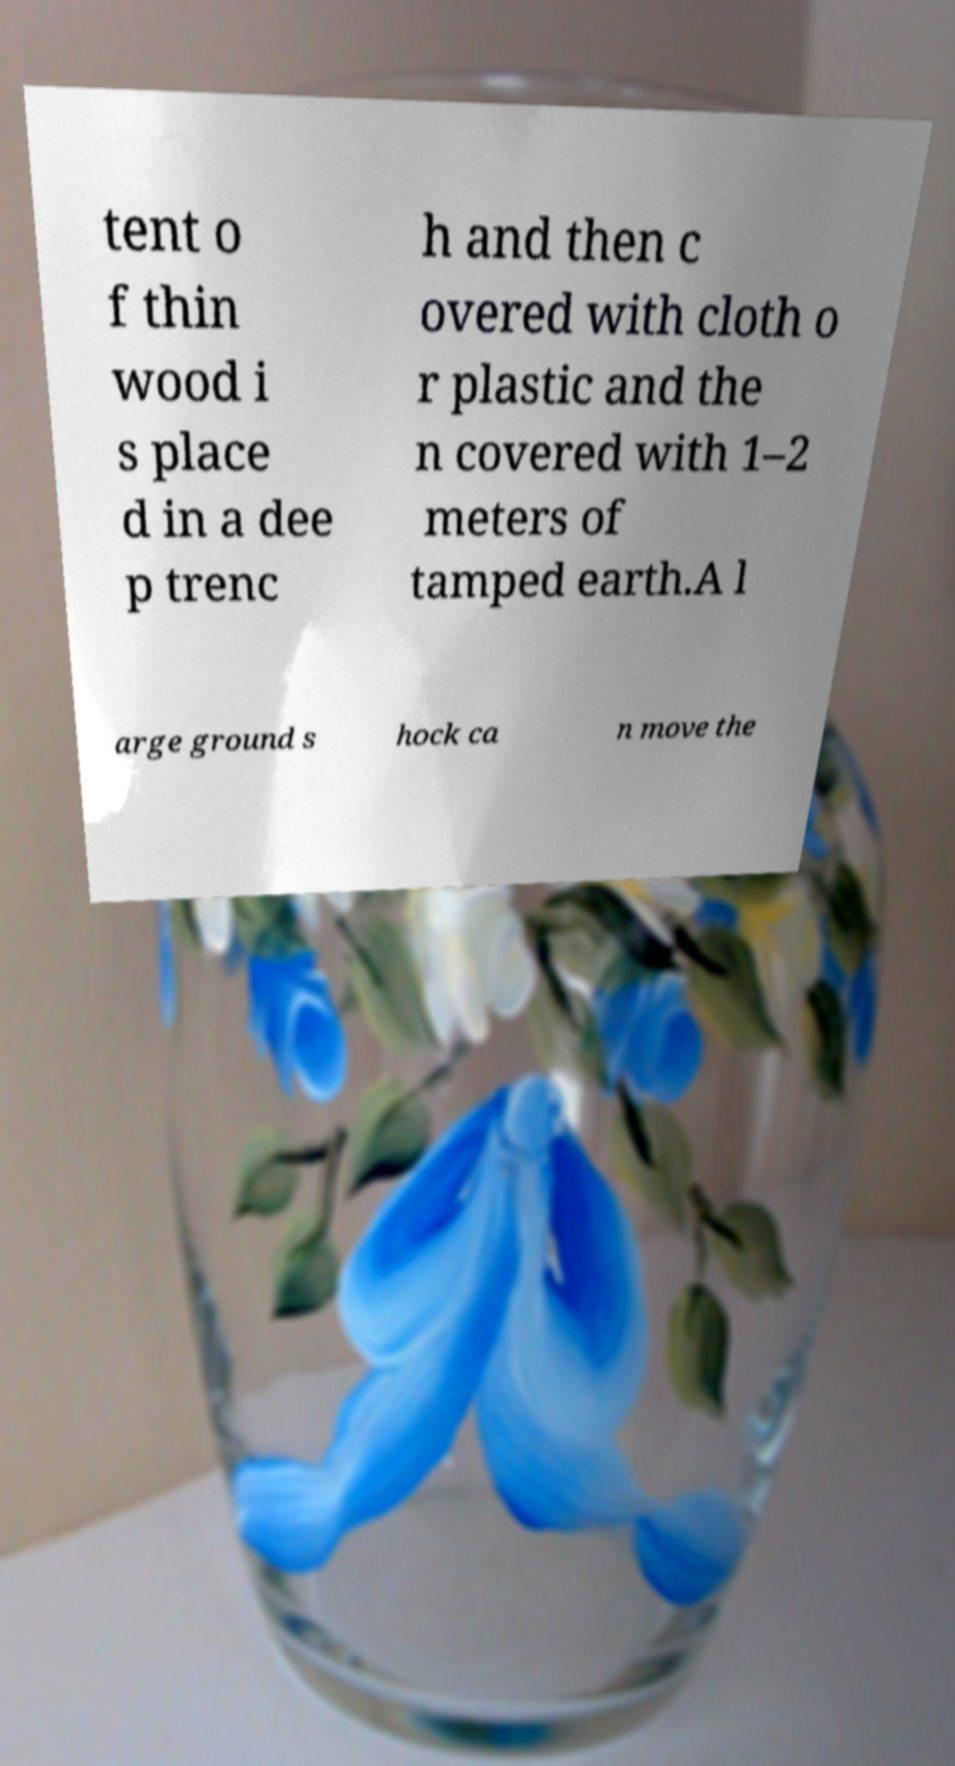There's text embedded in this image that I need extracted. Can you transcribe it verbatim? tent o f thin wood i s place d in a dee p trenc h and then c overed with cloth o r plastic and the n covered with 1–2 meters of tamped earth.A l arge ground s hock ca n move the 